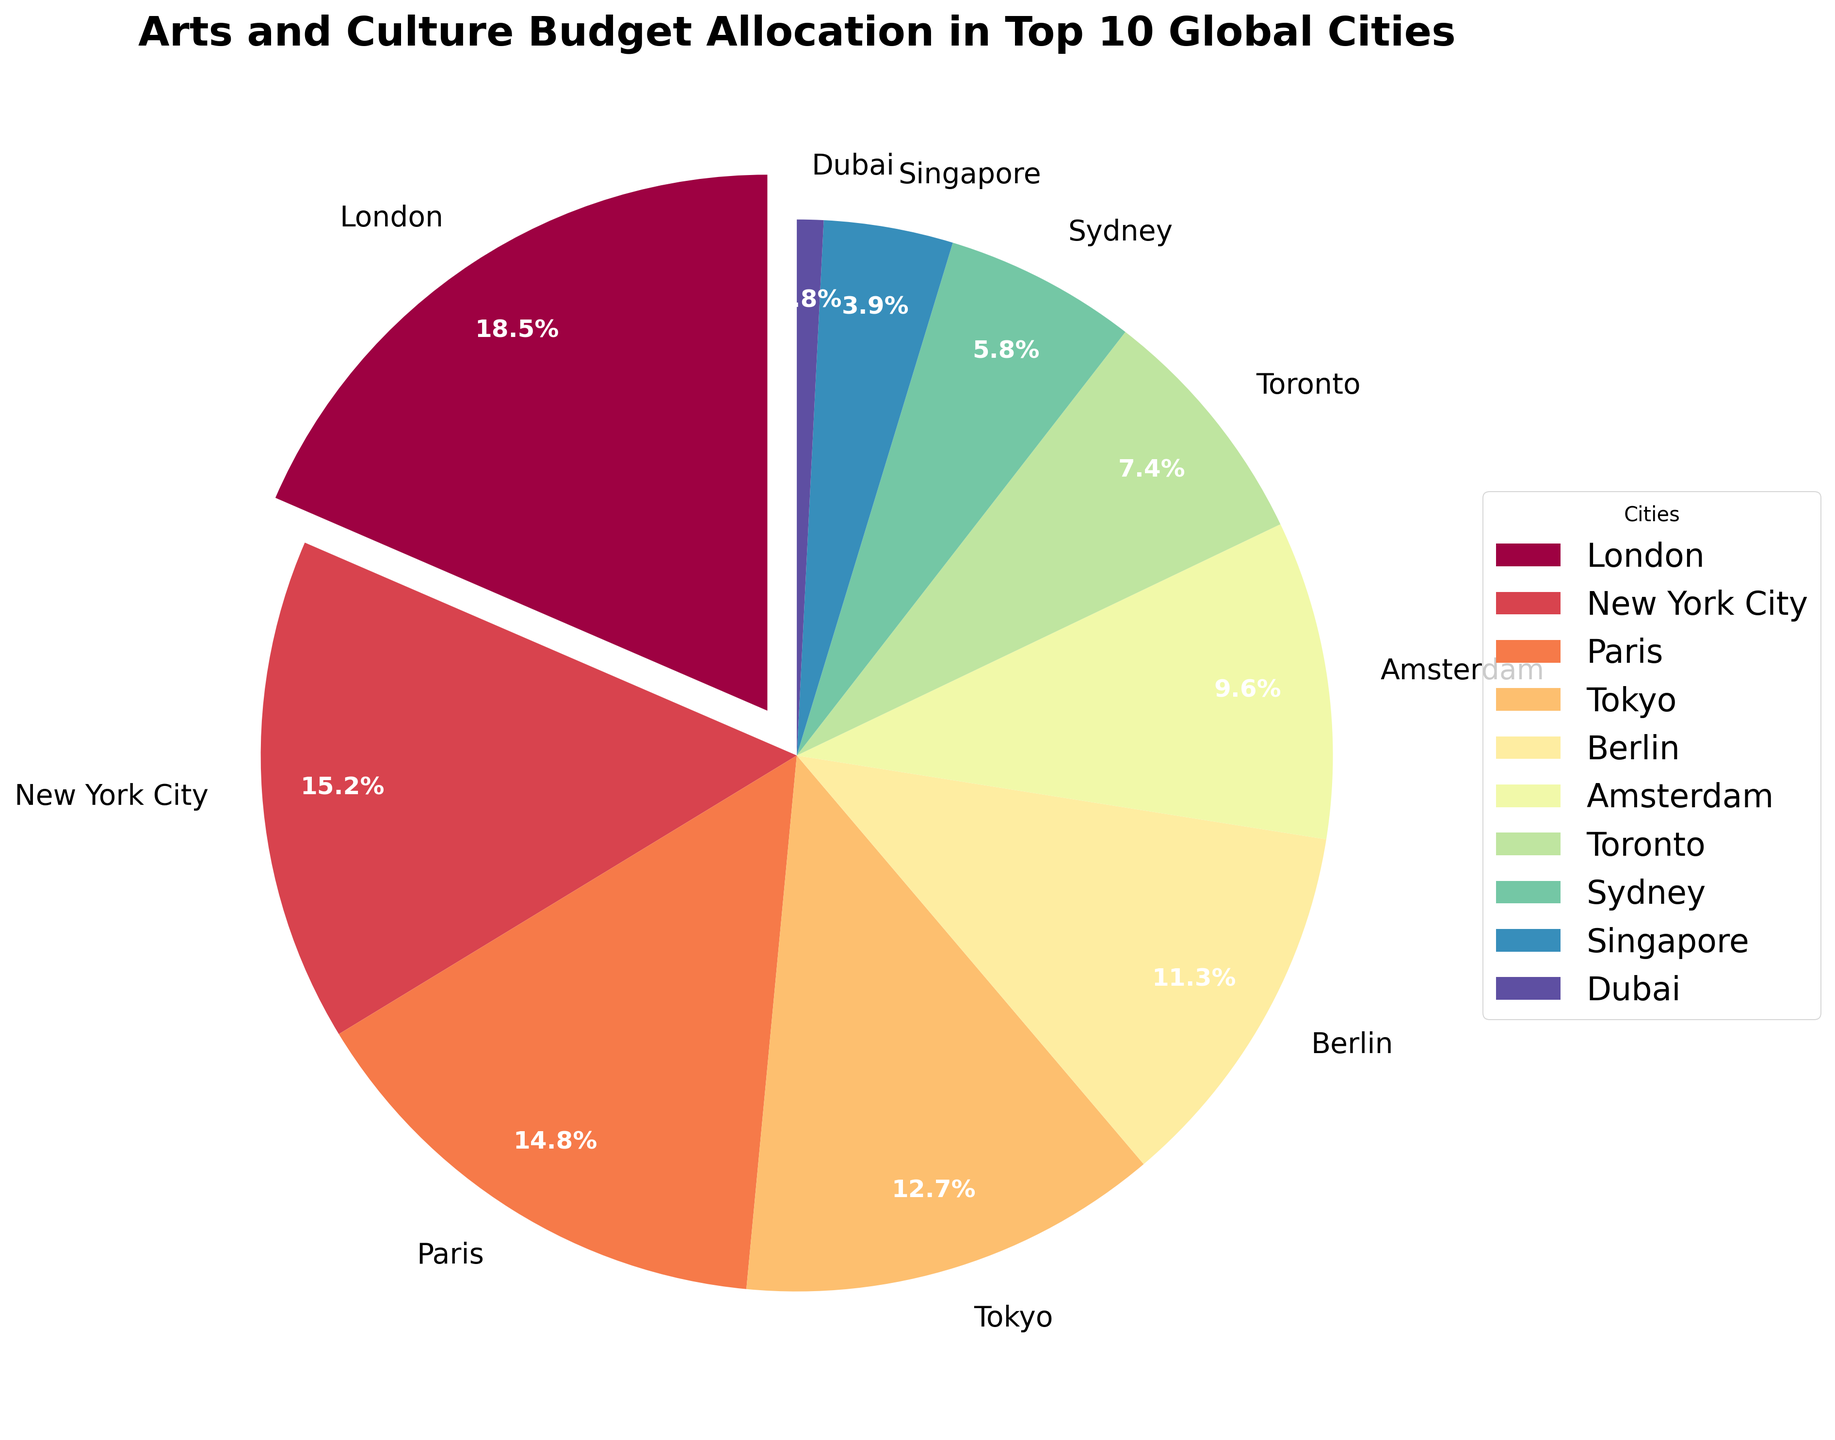what is the city with the least budget allocation for arts and culture? By looking at the visual information in the pie chart, the city with the smallest wedge is Dubai.
Answer: Dubai Which city has the highest budget allocation, and how much is it? The city with the largest wedge is London, with a budget allocation of 18.5%.
Answer: London, 18.5% How much more budget allocation does New York City have compared to Dubai? New York City's budget allocation is 15.2%, and Dubai's is 0.8%. The difference is 15.2% - 0.8% = 14.4%.
Answer: 14.4% Which cities together constitute more than 50% of the budget allocation? The budget allocations for London (18.5%), New York City (15.2%), and Paris (14.8%) sum up to 18.5% + 15.2% + 14.8% = 48.5%. Including Tokyo (12.7%), the total becomes 48.5% + 12.7% = 61.2%, which is more than 50%. So, London, New York City, Paris, and Tokyo together constitute more than 50%.
Answer: London, New York City, Paris, Tokyo What is the approximate average budget allocation for the top five cities? The top five cities (London, New York City, Paris, Tokyo, Berlin) have budget allocations of 18.5%, 15.2%, 14.8%, 12.7%, and 11.3%. The average is calculated as (18.5 + 15.2 + 14.8 + 12.7 + 11.3) / 5 = 72.5 / 5 = 14.5%.
Answer: 14.5% How does the budget allocation of Amsterdam compare to Sydney? Amsterdam's budget allocation is 9.6%, whereas Sydney's is 5.8%. Amsterdam's budget allocation is greater.
Answer: Amsterdam has more Combine the budget allocations of the cities from Europe and compare it with the total for the non-European cities. Which group has a higher allocation? European cities: London (18.5%), Paris (14.8%), Berlin (11.3%), and Amsterdam (9.6%). Summing up: 18.5 + 14.8 + 11.3 + 9.6 = 54.2%. Non-European cities: New York City (15.2%), Tokyo (12.7%), Toronto (7.4%), Sydney (5.8%), Singapore (3.9%), Dubai (0.8%). Summing up: 15.2 + 12.7 + 7.4 + 5.8 + 3.9 + 0.8 = 45.8%. The European cities have a higher allocation.
Answer: European cities What's the budget allocation range among the cities? The highest budget allocation is 18.5% (London), and the lowest is 0.8% (Dubai). The range is 18.5% - 0.8% = 17.7%.
Answer: 17.7% What is the dominant color in the pie chart? By observing the largest wedge in the chart, which represents London, the dominant color corresponding to that wedge can be identified.
Answer: The color of London's wedge 